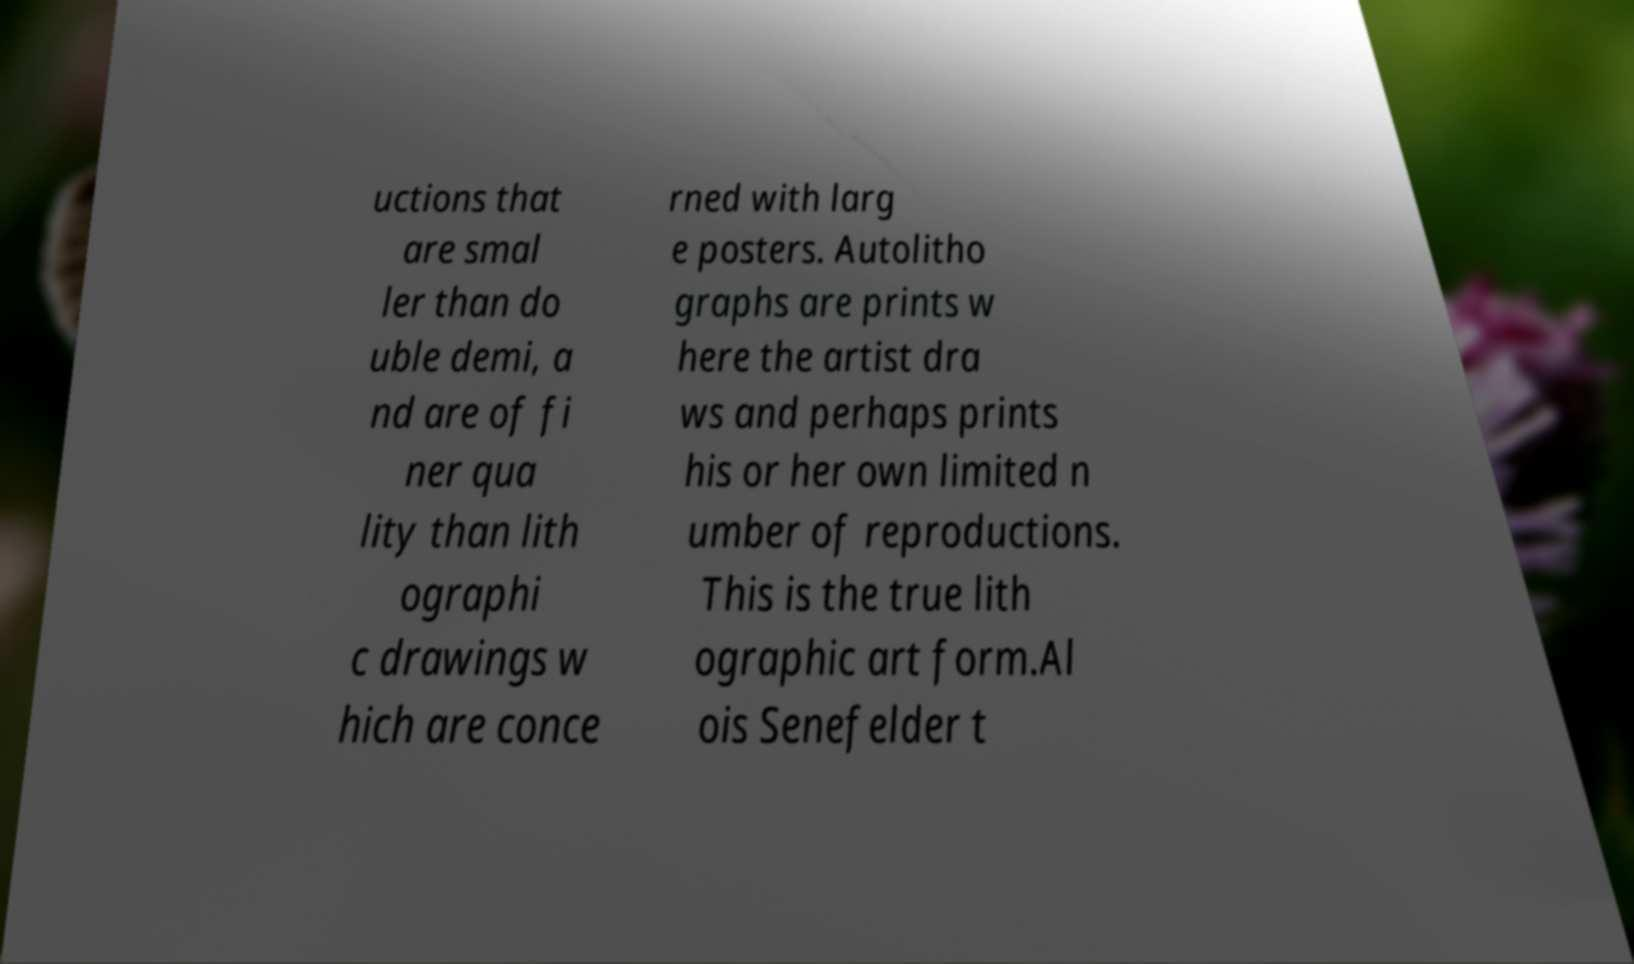Can you accurately transcribe the text from the provided image for me? uctions that are smal ler than do uble demi, a nd are of fi ner qua lity than lith ographi c drawings w hich are conce rned with larg e posters. Autolitho graphs are prints w here the artist dra ws and perhaps prints his or her own limited n umber of reproductions. This is the true lith ographic art form.Al ois Senefelder t 